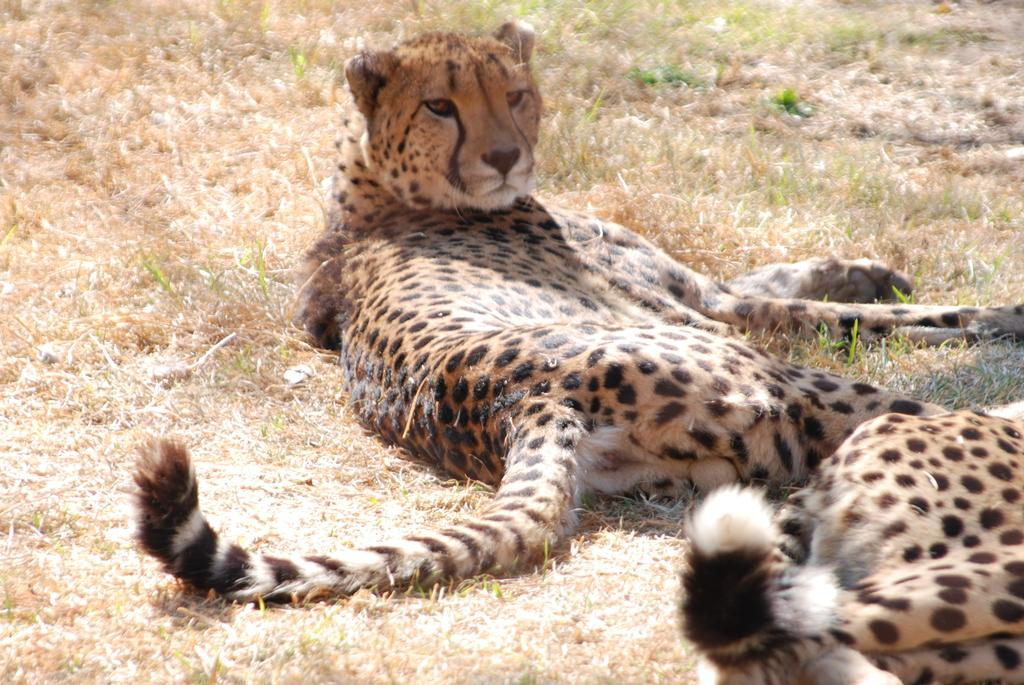What types of living organisms can be seen in the image? There are animals in the image. Where are the animals located in the image? The animals are on the ground. What type of shirt is the plant wearing in the image? There is no shirt or plant present in the image; it features animals on the ground. What is the lead doing in the image? There is no lead present in the image. 